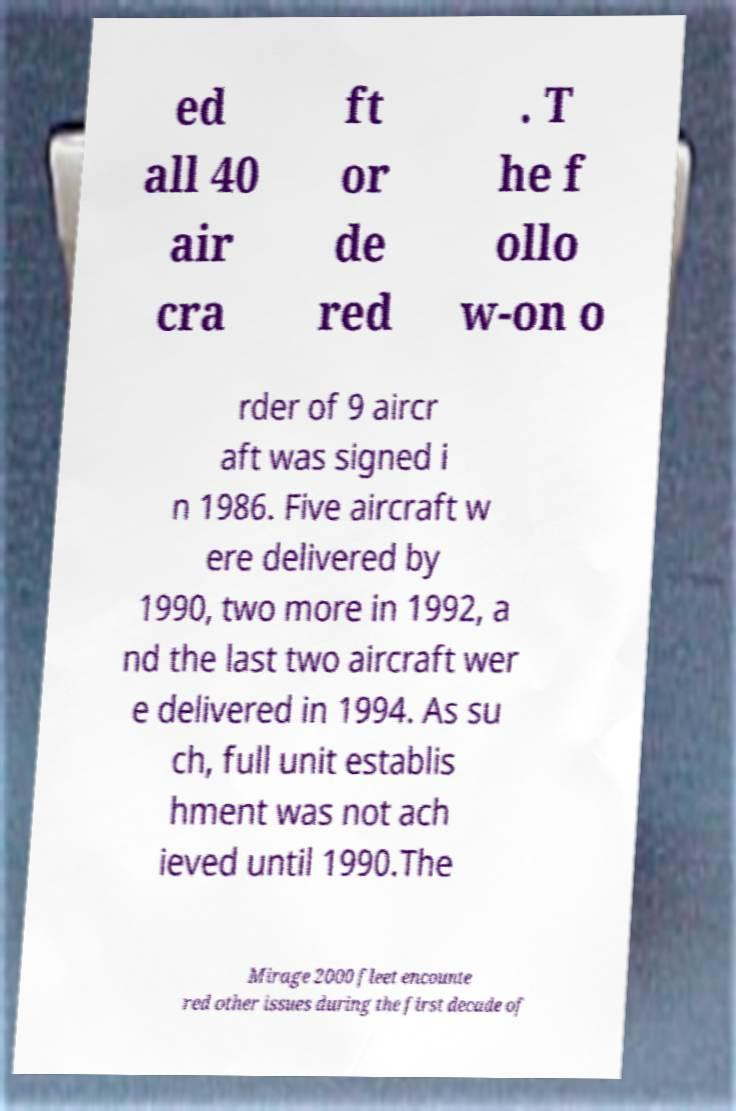Can you accurately transcribe the text from the provided image for me? ed all 40 air cra ft or de red . T he f ollo w-on o rder of 9 aircr aft was signed i n 1986. Five aircraft w ere delivered by 1990, two more in 1992, a nd the last two aircraft wer e delivered in 1994. As su ch, full unit establis hment was not ach ieved until 1990.The Mirage 2000 fleet encounte red other issues during the first decade of 